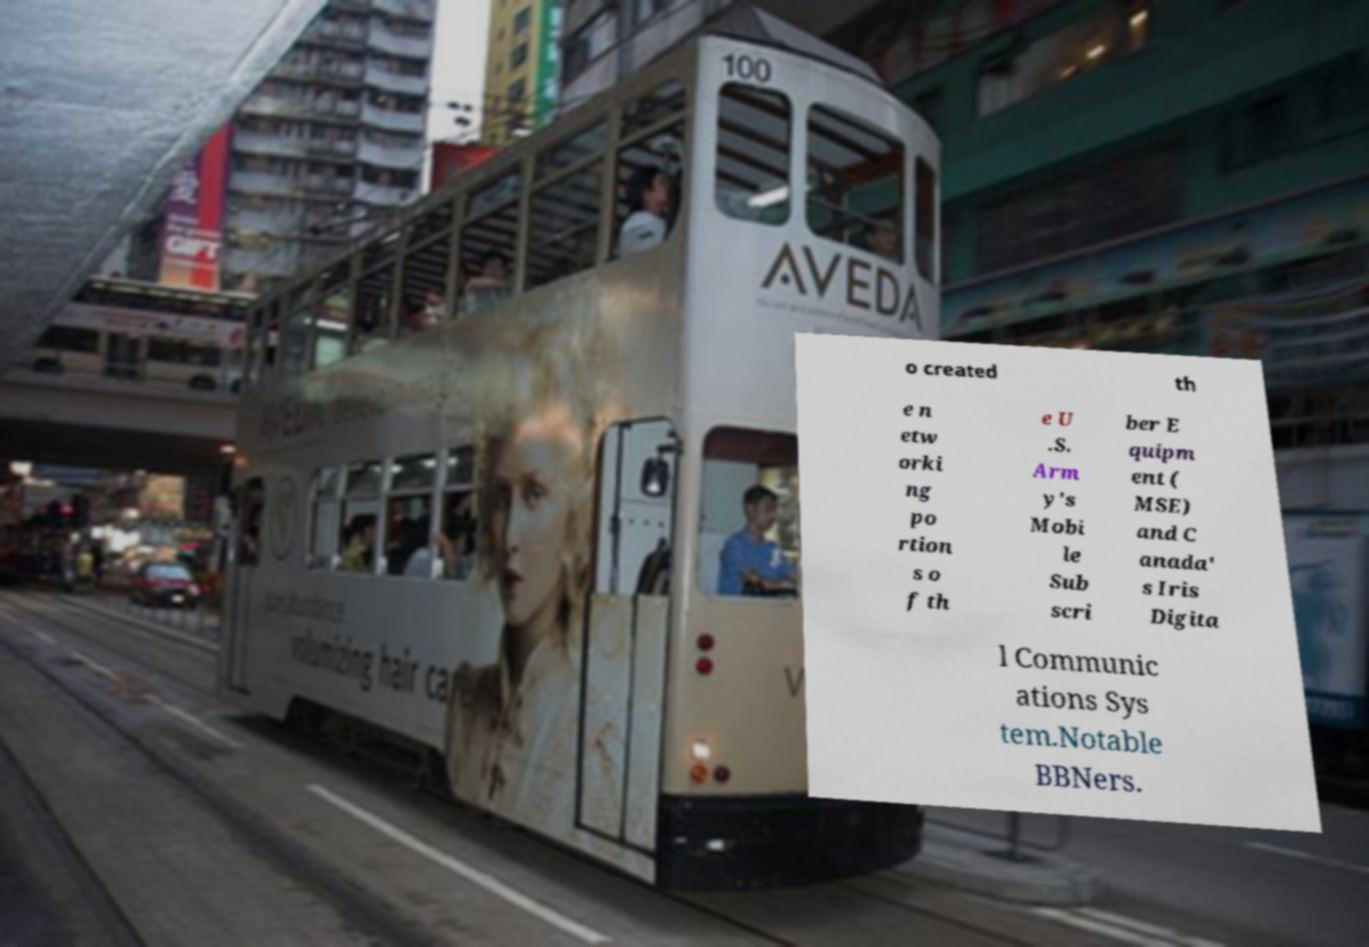Please identify and transcribe the text found in this image. o created th e n etw orki ng po rtion s o f th e U .S. Arm y's Mobi le Sub scri ber E quipm ent ( MSE) and C anada' s Iris Digita l Communic ations Sys tem.Notable BBNers. 